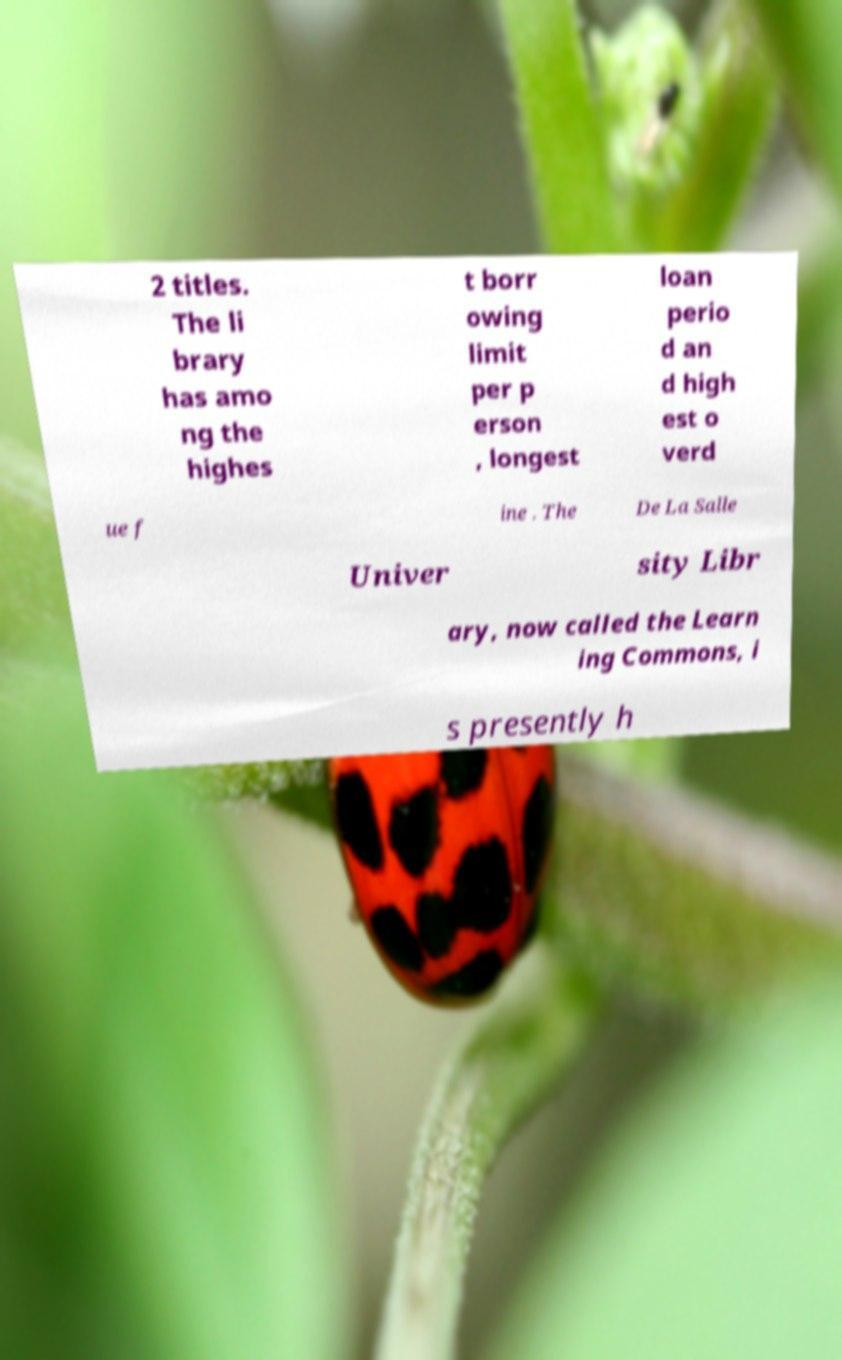Please identify and transcribe the text found in this image. 2 titles. The li brary has amo ng the highes t borr owing limit per p erson , longest loan perio d an d high est o verd ue f ine . The De La Salle Univer sity Libr ary, now called the Learn ing Commons, i s presently h 